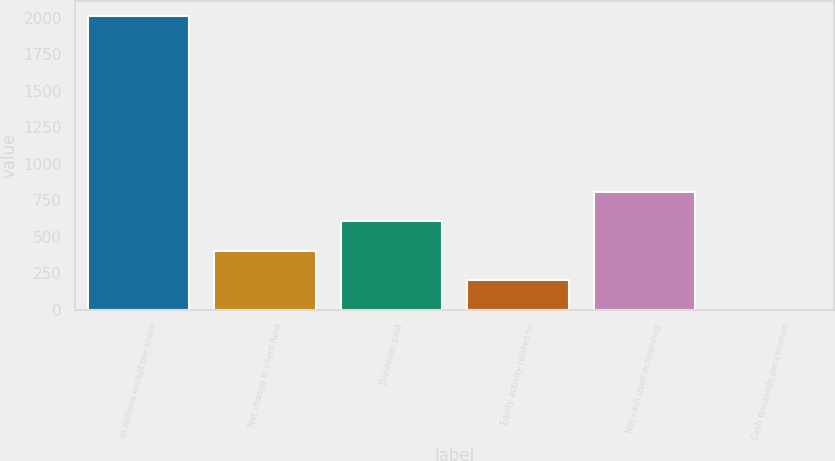Convert chart to OTSL. <chart><loc_0><loc_0><loc_500><loc_500><bar_chart><fcel>In millions except per share<fcel>Net change in client fund<fcel>Dividends paid<fcel>Equity activity related to<fcel>Net cash used in financing<fcel>Cash dividends per common<nl><fcel>2015<fcel>404.22<fcel>605.57<fcel>202.87<fcel>806.92<fcel>1.52<nl></chart> 